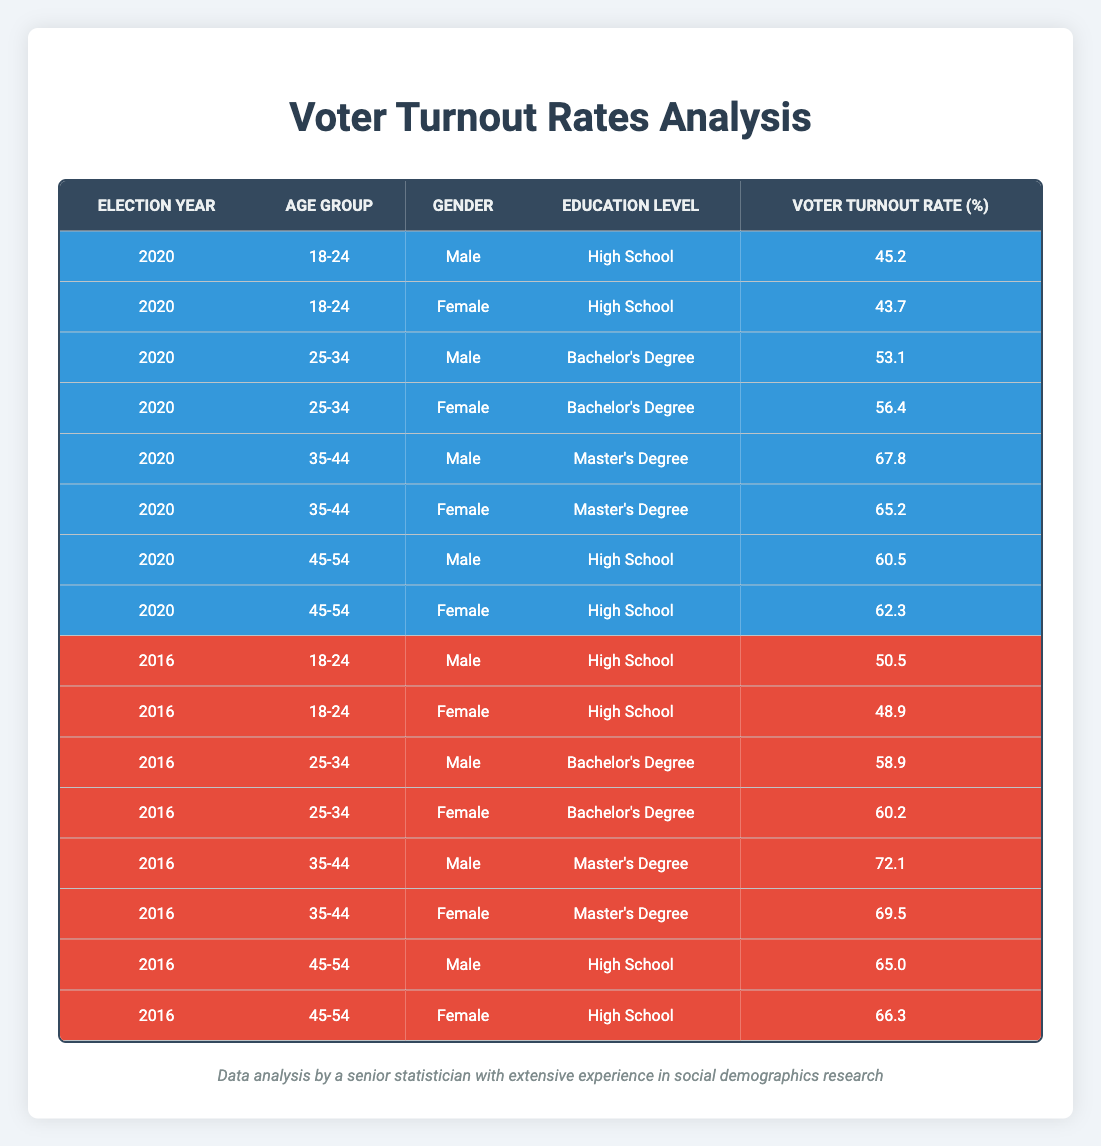What was the voter turnout rate for female voters aged 25-34 in 2020? The table shows the voter turnout rate for female voters in the age group 25-34 for the year 2020. Looking at the row corresponding to 2020, age group 25-34, gender female, the turnout rate is listed as 56.4.
Answer: 56.4 Was the voter turnout rate for males aged 45-54 higher in 2016 or 2020? To determine this, we look for the voter turnout rate for males aged 45-54 in both years. In 2016, it was 65.0, while in 2020 it was 60.5. Since 65.0 (2016) is greater than 60.5 (2020), we conclude that it was higher in 2016.
Answer: 2016 What is the average voter turnout rate for males across all age groups in 2020? First, we identify the rows for males in the year 2020. They are as follows: 45.2 (18-24), 53.1 (25-34), 67.8 (35-44), and 60.5 (45-54). Next, we sum these rates: 45.2 + 53.1 + 67.8 + 60.5 = 226.6. There are 4 data points, so we calculate the average as: 226.6 / 4 = 56.65.
Answer: 56.65 Is it true that the voter turnout rate for females aged 18-24 decreased from 2016 to 2020? We check the turnout rate for females aged 18-24 for both years. In 2016, the rate was 48.9, and in 2020, it was 43.7. Since 43.7 is less than 48.9, it is true that the turnout decreased.
Answer: Yes Which age group had the highest voter turnout rate for males in 2016? To find this, we look at the voter turnout rates for males in 2016: 50.5 (18-24), 58.9 (25-34), 72.1 (35-44), and 65.0 (45-54). The highest value among these is 72.1 from the age group 35-44.
Answer: 35-44 